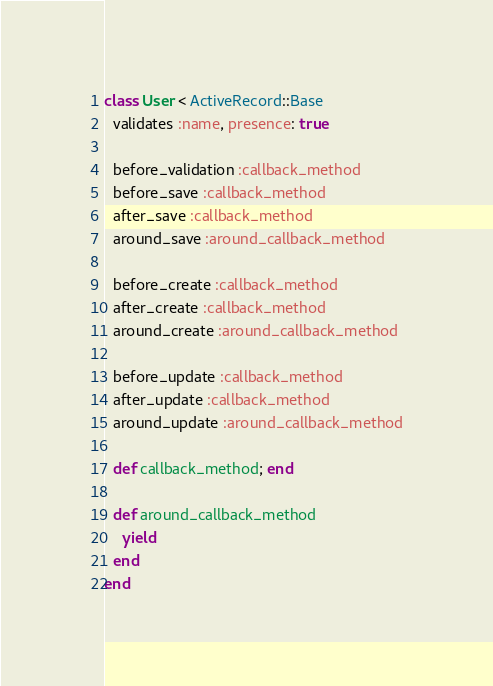Convert code to text. <code><loc_0><loc_0><loc_500><loc_500><_Ruby_>class User < ActiveRecord::Base
  validates :name, presence: true

  before_validation :callback_method
  before_save :callback_method
  after_save :callback_method
  around_save :around_callback_method

  before_create :callback_method
  after_create :callback_method
  around_create :around_callback_method

  before_update :callback_method
  after_update :callback_method
  around_update :around_callback_method

  def callback_method; end

  def around_callback_method
    yield
  end
end
</code> 